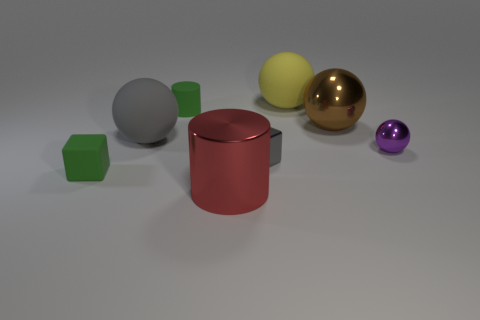What can you infer about the lighting of this scene? The lighting in the scene seems to be soft and diffused, with gentle shadows indicating an overhead light source, perhaps suggesting an indoor setting with controlled lighting, such as a studio or a classroom environment used for instructional purposes. 